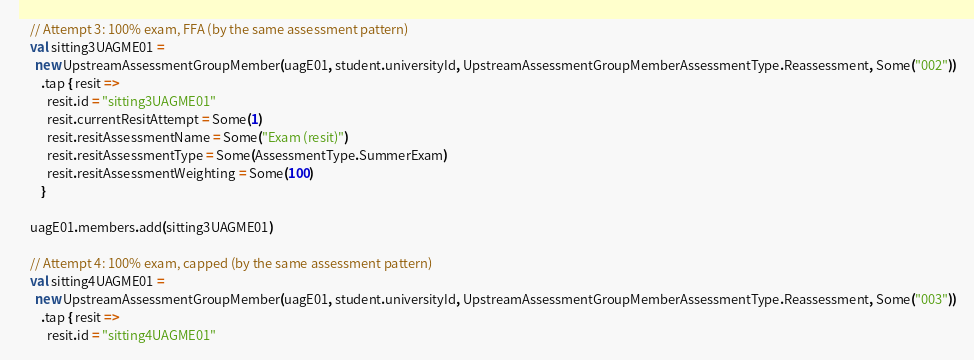<code> <loc_0><loc_0><loc_500><loc_500><_Scala_>
    // Attempt 3: 100% exam, FFA (by the same assessment pattern)
    val sitting3UAGME01 =
      new UpstreamAssessmentGroupMember(uagE01, student.universityId, UpstreamAssessmentGroupMemberAssessmentType.Reassessment, Some("002"))
        .tap { resit =>
          resit.id = "sitting3UAGME01"
          resit.currentResitAttempt = Some(1)
          resit.resitAssessmentName = Some("Exam (resit)")
          resit.resitAssessmentType = Some(AssessmentType.SummerExam)
          resit.resitAssessmentWeighting = Some(100)
        }

    uagE01.members.add(sitting3UAGME01)

    // Attempt 4: 100% exam, capped (by the same assessment pattern)
    val sitting4UAGME01 =
      new UpstreamAssessmentGroupMember(uagE01, student.universityId, UpstreamAssessmentGroupMemberAssessmentType.Reassessment, Some("003"))
        .tap { resit =>
          resit.id = "sitting4UAGME01"</code> 